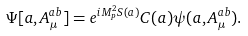<formula> <loc_0><loc_0><loc_500><loc_500>\Psi [ a , A ^ { a b } _ { \mu } ] = e ^ { i M _ { P } ^ { 2 } S ( a ) } C ( a ) \psi ( a , A ^ { a b } _ { \mu } ) .</formula> 